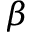Convert formula to latex. <formula><loc_0><loc_0><loc_500><loc_500>\beta</formula> 